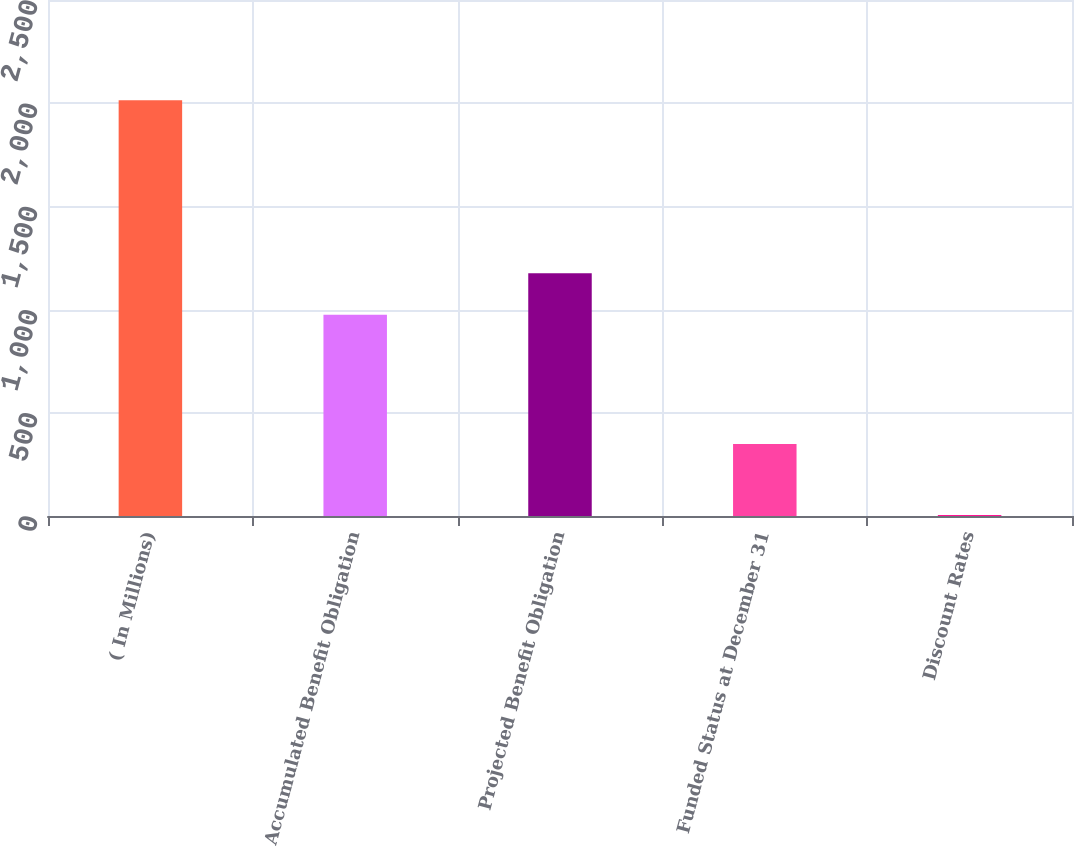Convert chart. <chart><loc_0><loc_0><loc_500><loc_500><bar_chart><fcel>( In Millions)<fcel>Accumulated Benefit Obligation<fcel>Projected Benefit Obligation<fcel>Funded Status at December 31<fcel>Discount Rates<nl><fcel>2014<fcel>974.8<fcel>1175.78<fcel>349.3<fcel>4.25<nl></chart> 